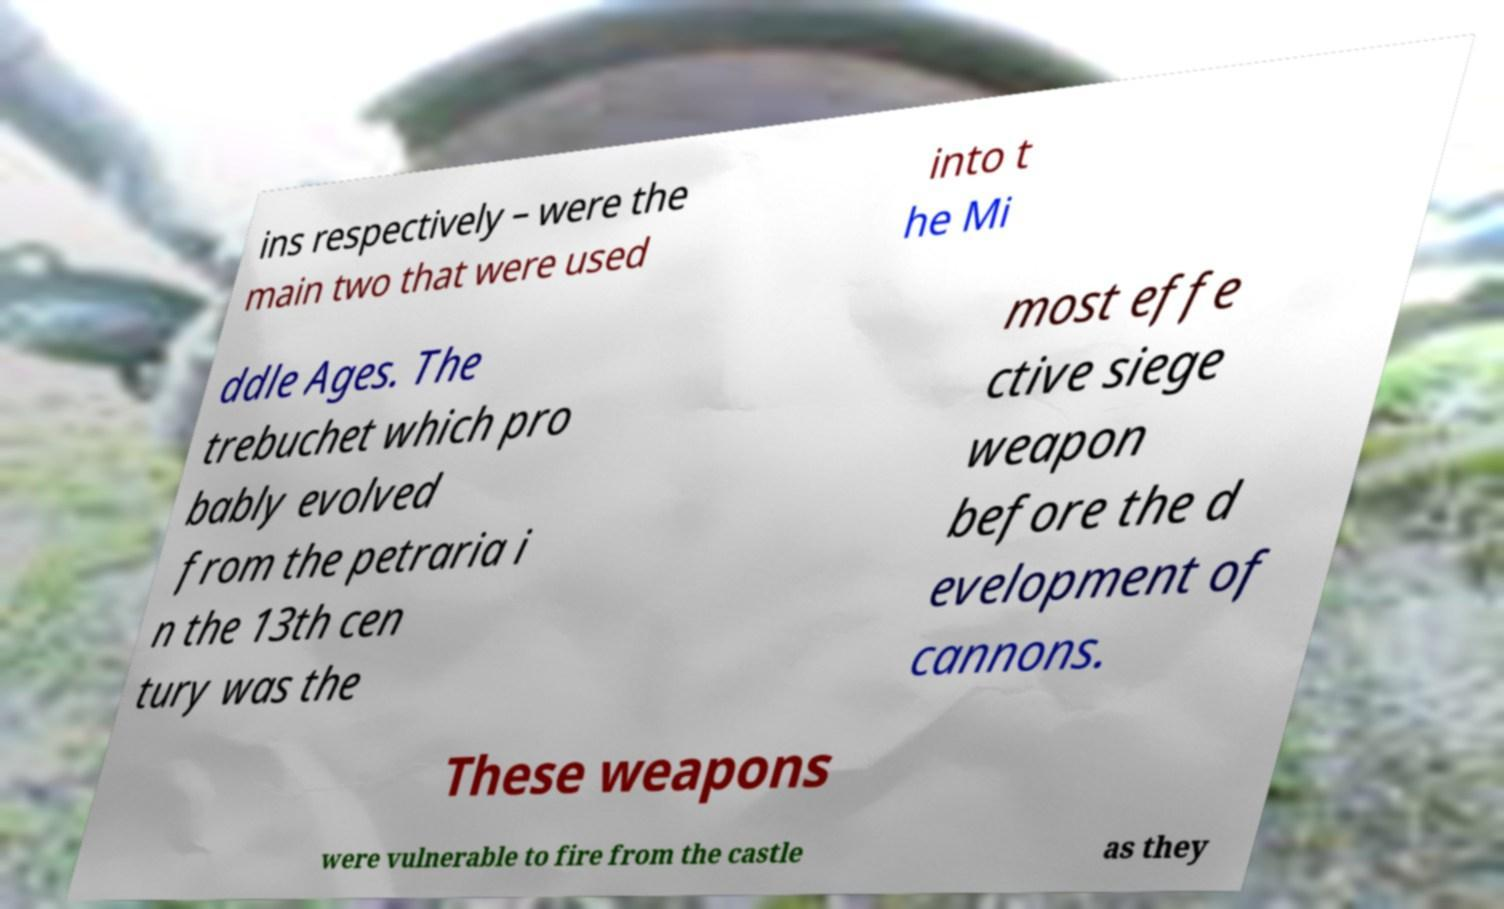For documentation purposes, I need the text within this image transcribed. Could you provide that? ins respectively – were the main two that were used into t he Mi ddle Ages. The trebuchet which pro bably evolved from the petraria i n the 13th cen tury was the most effe ctive siege weapon before the d evelopment of cannons. These weapons were vulnerable to fire from the castle as they 